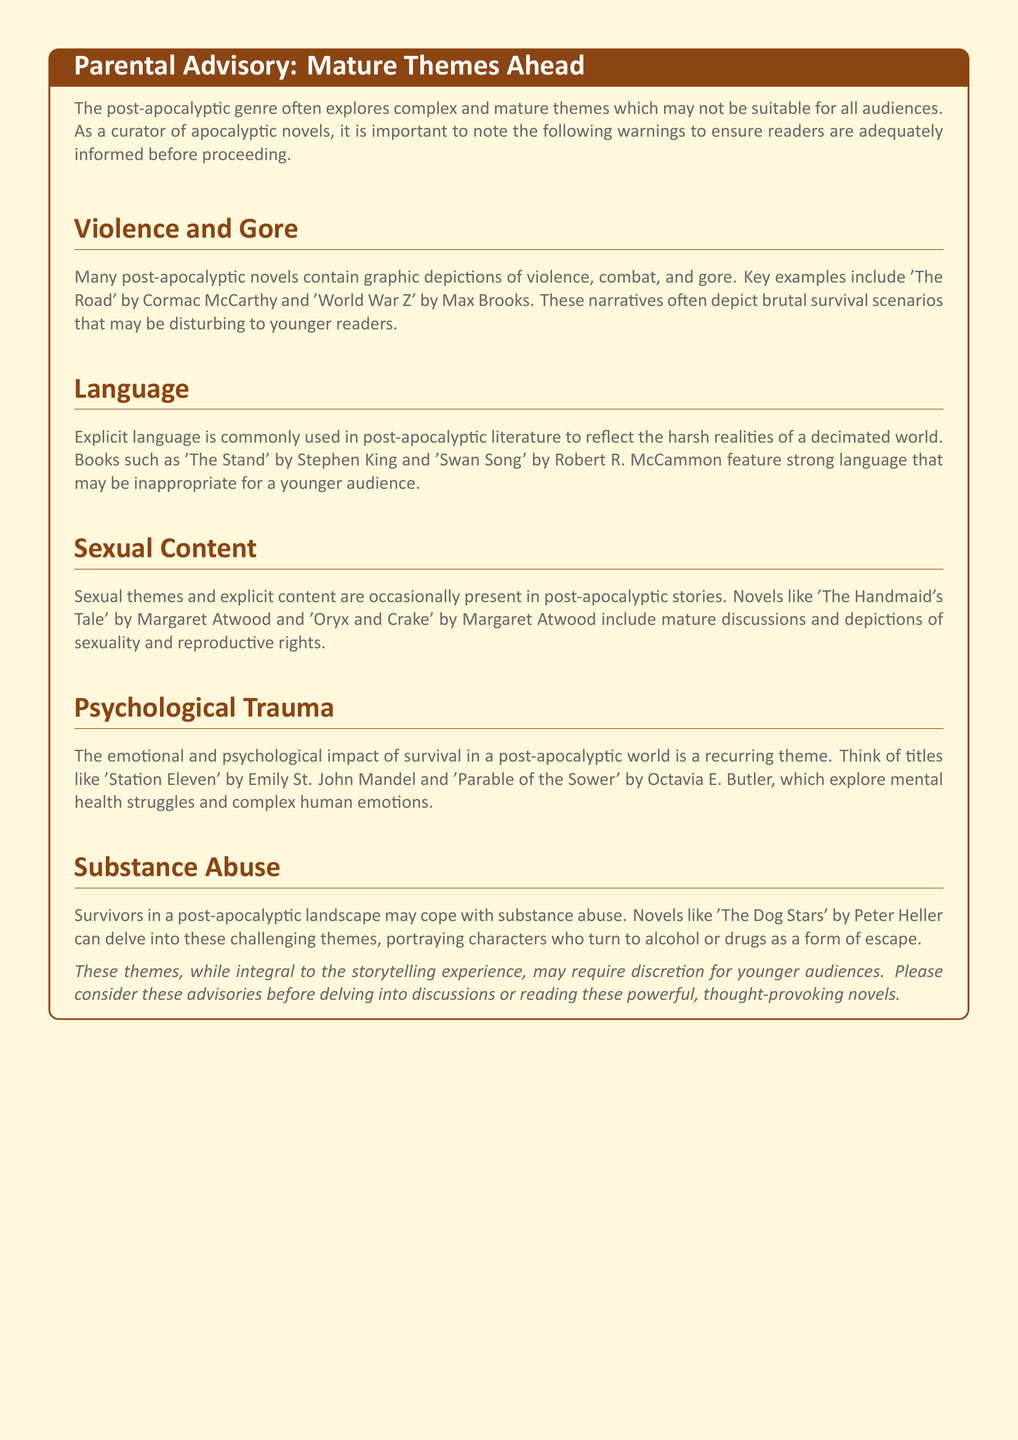What is the title of the advisory? The title of the advisory is prominently stated at the top of the warning box.
Answer: Parental Advisory: Mature Themes Ahead Which novel is mentioned first under Violence and Gore? The first novel mentioned under the section for Violence and Gore serves as a prime example of graphic content.
Answer: The Road How many mature themes are highlighted in the document? The document outlines a total of five distinct mature themes that require caution.
Answer: Five Who is the author of 'Station Eleven'? The author of this particular book is noted in the document as part of a discussion on psychological trauma.
Answer: Emily St. John Mandel Which genre is the focus of the advisory? The advisory points to a specific genre as a context for discussing disturbing themes.
Answer: Post-apocalyptic What type of themes does the document warn may be inappropriate for younger audiences? The document specifies themes that may not be suitable for all readers due to their mature nature.
Answer: Mature themes 